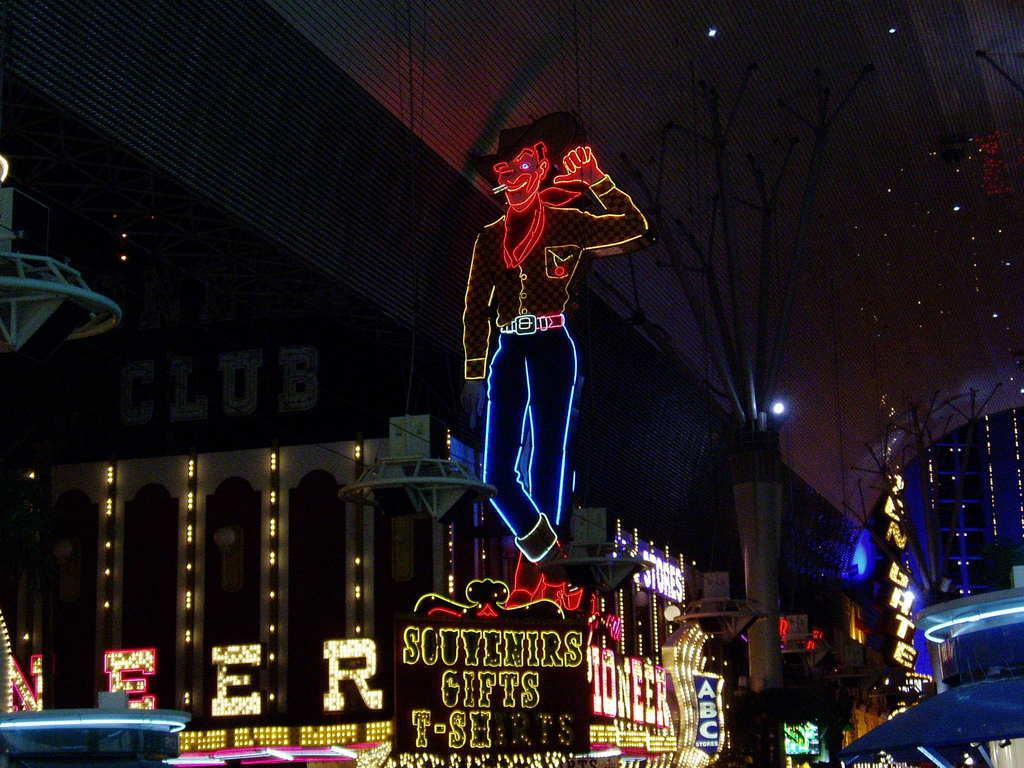What type of lighting is present in the image? There are decorative lights in the image. What type of structures can be seen in the image? There are buildings in the image. What type of screens are visible in the image? There are LCD screens in the image. What type of advertising is present in the image? There are hoardings in the image. What type of coach is visible in the image? There is no coach present in the image. What need does the stem of the plant in the image fulfill? There is no plant or stem present in the image. 